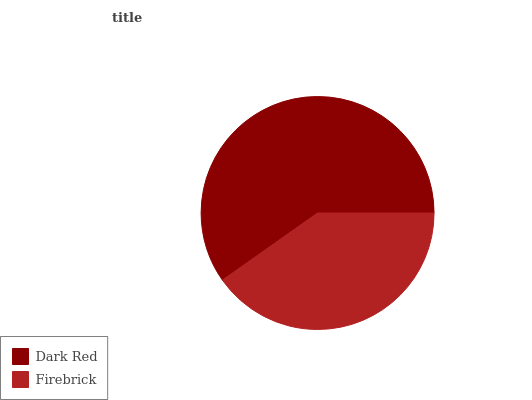Is Firebrick the minimum?
Answer yes or no. Yes. Is Dark Red the maximum?
Answer yes or no. Yes. Is Firebrick the maximum?
Answer yes or no. No. Is Dark Red greater than Firebrick?
Answer yes or no. Yes. Is Firebrick less than Dark Red?
Answer yes or no. Yes. Is Firebrick greater than Dark Red?
Answer yes or no. No. Is Dark Red less than Firebrick?
Answer yes or no. No. Is Dark Red the high median?
Answer yes or no. Yes. Is Firebrick the low median?
Answer yes or no. Yes. Is Firebrick the high median?
Answer yes or no. No. Is Dark Red the low median?
Answer yes or no. No. 